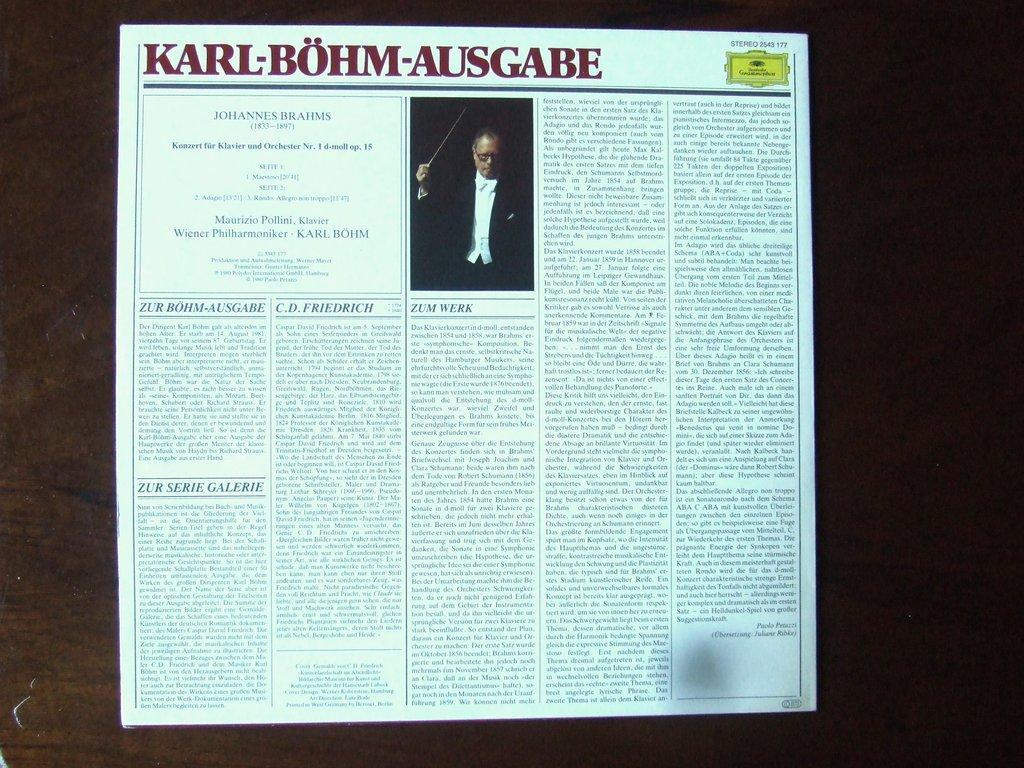Can you describe this image briefly? In the center of the image there is a newspaper in which there is a person wearing a black color suit. 